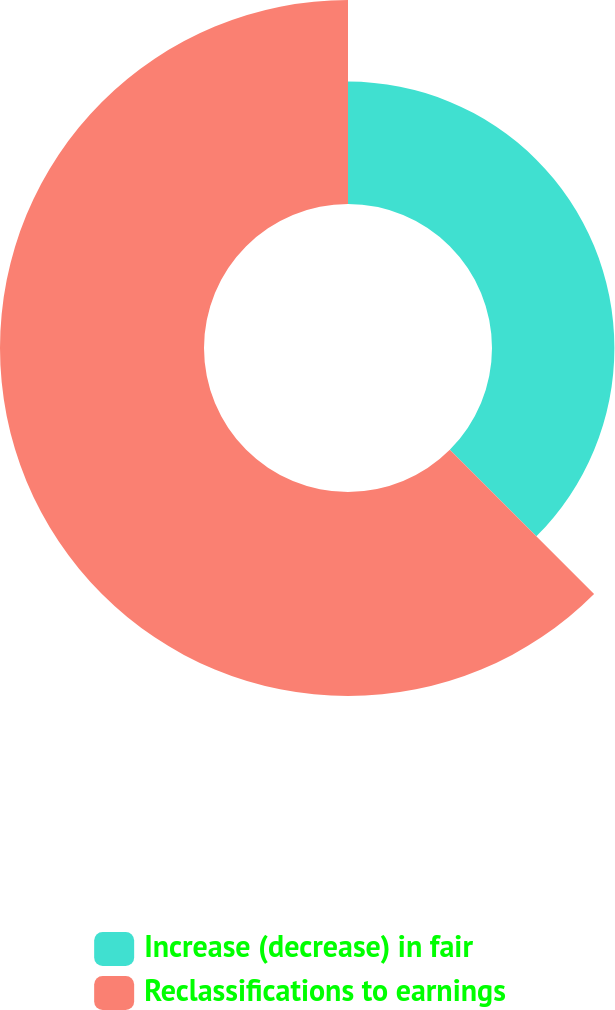Convert chart to OTSL. <chart><loc_0><loc_0><loc_500><loc_500><pie_chart><fcel>Increase (decrease) in fair<fcel>Reclassifications to earnings<nl><fcel>37.5%<fcel>62.5%<nl></chart> 